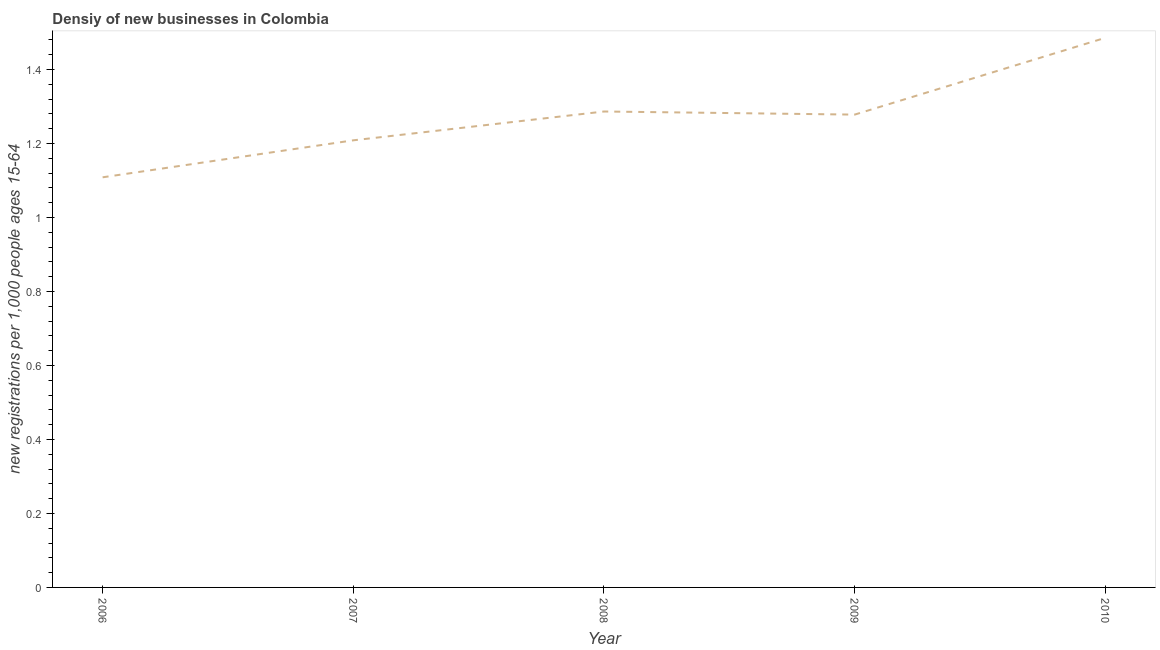What is the density of new business in 2009?
Offer a terse response. 1.28. Across all years, what is the maximum density of new business?
Give a very brief answer. 1.49. Across all years, what is the minimum density of new business?
Give a very brief answer. 1.11. In which year was the density of new business minimum?
Make the answer very short. 2006. What is the sum of the density of new business?
Your answer should be compact. 6.37. What is the difference between the density of new business in 2007 and 2009?
Your answer should be very brief. -0.07. What is the average density of new business per year?
Your answer should be very brief. 1.27. What is the median density of new business?
Offer a terse response. 1.28. In how many years, is the density of new business greater than 0.04 ?
Your answer should be very brief. 5. What is the ratio of the density of new business in 2009 to that in 2010?
Offer a very short reply. 0.86. Is the density of new business in 2006 less than that in 2007?
Make the answer very short. Yes. What is the difference between the highest and the second highest density of new business?
Ensure brevity in your answer.  0.2. What is the difference between the highest and the lowest density of new business?
Offer a terse response. 0.38. What is the difference between two consecutive major ticks on the Y-axis?
Make the answer very short. 0.2. Are the values on the major ticks of Y-axis written in scientific E-notation?
Make the answer very short. No. Does the graph contain any zero values?
Provide a succinct answer. No. What is the title of the graph?
Your answer should be compact. Densiy of new businesses in Colombia. What is the label or title of the Y-axis?
Your answer should be compact. New registrations per 1,0 people ages 15-64. What is the new registrations per 1,000 people ages 15-64 in 2006?
Offer a very short reply. 1.11. What is the new registrations per 1,000 people ages 15-64 in 2007?
Provide a short and direct response. 1.21. What is the new registrations per 1,000 people ages 15-64 of 2008?
Give a very brief answer. 1.29. What is the new registrations per 1,000 people ages 15-64 of 2009?
Provide a succinct answer. 1.28. What is the new registrations per 1,000 people ages 15-64 of 2010?
Give a very brief answer. 1.49. What is the difference between the new registrations per 1,000 people ages 15-64 in 2006 and 2007?
Keep it short and to the point. -0.1. What is the difference between the new registrations per 1,000 people ages 15-64 in 2006 and 2008?
Provide a succinct answer. -0.18. What is the difference between the new registrations per 1,000 people ages 15-64 in 2006 and 2009?
Your answer should be compact. -0.17. What is the difference between the new registrations per 1,000 people ages 15-64 in 2006 and 2010?
Keep it short and to the point. -0.38. What is the difference between the new registrations per 1,000 people ages 15-64 in 2007 and 2008?
Your answer should be very brief. -0.08. What is the difference between the new registrations per 1,000 people ages 15-64 in 2007 and 2009?
Keep it short and to the point. -0.07. What is the difference between the new registrations per 1,000 people ages 15-64 in 2007 and 2010?
Your answer should be very brief. -0.28. What is the difference between the new registrations per 1,000 people ages 15-64 in 2008 and 2009?
Provide a short and direct response. 0.01. What is the difference between the new registrations per 1,000 people ages 15-64 in 2008 and 2010?
Provide a succinct answer. -0.2. What is the difference between the new registrations per 1,000 people ages 15-64 in 2009 and 2010?
Offer a terse response. -0.21. What is the ratio of the new registrations per 1,000 people ages 15-64 in 2006 to that in 2007?
Offer a very short reply. 0.92. What is the ratio of the new registrations per 1,000 people ages 15-64 in 2006 to that in 2008?
Provide a succinct answer. 0.86. What is the ratio of the new registrations per 1,000 people ages 15-64 in 2006 to that in 2009?
Keep it short and to the point. 0.87. What is the ratio of the new registrations per 1,000 people ages 15-64 in 2006 to that in 2010?
Make the answer very short. 0.75. What is the ratio of the new registrations per 1,000 people ages 15-64 in 2007 to that in 2008?
Provide a short and direct response. 0.94. What is the ratio of the new registrations per 1,000 people ages 15-64 in 2007 to that in 2009?
Provide a short and direct response. 0.95. What is the ratio of the new registrations per 1,000 people ages 15-64 in 2007 to that in 2010?
Offer a very short reply. 0.81. What is the ratio of the new registrations per 1,000 people ages 15-64 in 2008 to that in 2010?
Give a very brief answer. 0.87. What is the ratio of the new registrations per 1,000 people ages 15-64 in 2009 to that in 2010?
Your response must be concise. 0.86. 